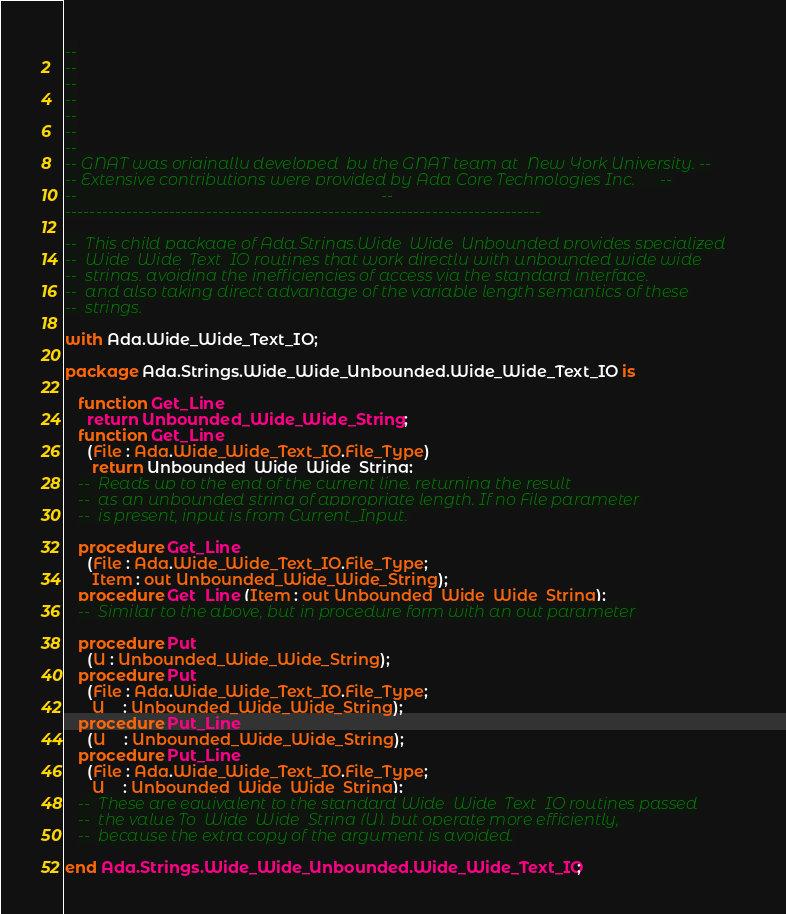Convert code to text. <code><loc_0><loc_0><loc_500><loc_500><_Ada_>--
--
--
--
--
--
--
-- GNAT was originally developed  by the GNAT team at  New York University. --
-- Extensive contributions were provided by Ada Core Technologies Inc.      --
--                                                                          --
------------------------------------------------------------------------------

--  This child package of Ada.Strings.Wide_Wide_Unbounded provides specialized
--  Wide_Wide_Text_IO routines that work directly with unbounded wide wide
--  strings, avoiding the inefficiencies of access via the standard interface,
--  and also taking direct advantage of the variable length semantics of these
--  strings.

with Ada.Wide_Wide_Text_IO;

package Ada.Strings.Wide_Wide_Unbounded.Wide_Wide_Text_IO is

   function Get_Line
     return Unbounded_Wide_Wide_String;
   function Get_Line
     (File : Ada.Wide_Wide_Text_IO.File_Type)
      return Unbounded_Wide_Wide_String;
   --  Reads up to the end of the current line, returning the result
   --  as an unbounded string of appropriate length. If no File parameter
   --  is present, input is from Current_Input.

   procedure Get_Line
     (File : Ada.Wide_Wide_Text_IO.File_Type;
      Item : out Unbounded_Wide_Wide_String);
   procedure Get_Line (Item : out Unbounded_Wide_Wide_String);
   --  Similar to the above, but in procedure form with an out parameter

   procedure Put
     (U : Unbounded_Wide_Wide_String);
   procedure Put
     (File : Ada.Wide_Wide_Text_IO.File_Type;
      U    : Unbounded_Wide_Wide_String);
   procedure Put_Line
     (U    : Unbounded_Wide_Wide_String);
   procedure Put_Line
     (File : Ada.Wide_Wide_Text_IO.File_Type;
      U    : Unbounded_Wide_Wide_String);
   --  These are equivalent to the standard Wide_Wide_Text_IO routines passed
   --  the value To_Wide_Wide_String (U), but operate more efficiently,
   --  because the extra copy of the argument is avoided.

end Ada.Strings.Wide_Wide_Unbounded.Wide_Wide_Text_IO;
</code> 